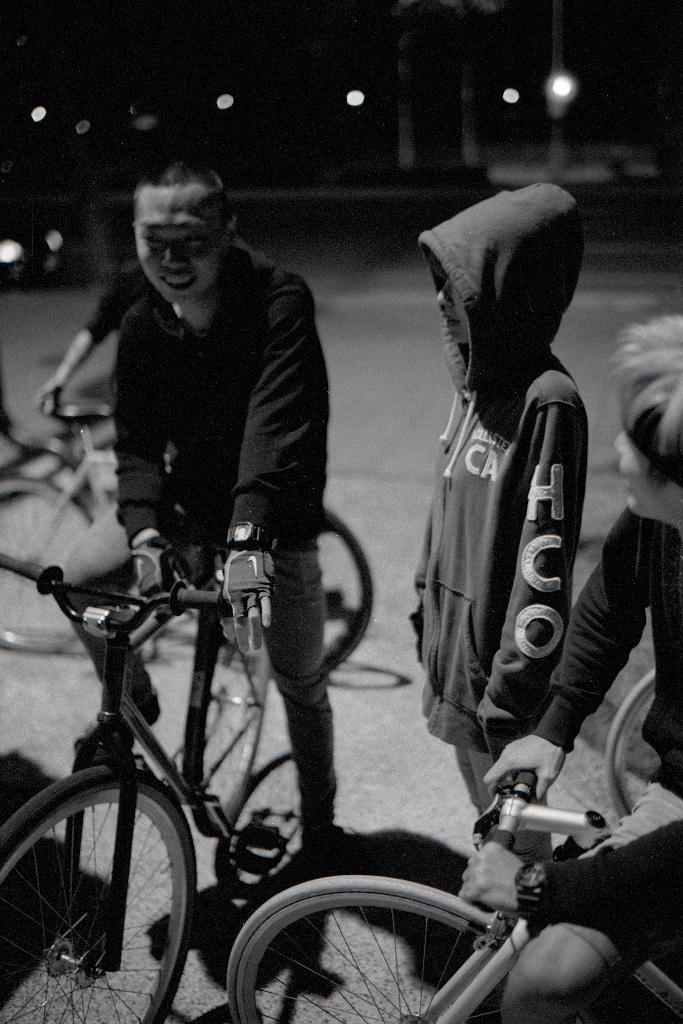Who is the main subject in the image? There is a man in the image. What is the man doing in the image? The man is sitting on a bicycle. Where is the man located in the image? The man is on the left side of the image. Can you describe the other person in the image? There is a person standing on the road in the image. What type of metal is the man touching in the image? There is no metal present in the image for the man to touch. 